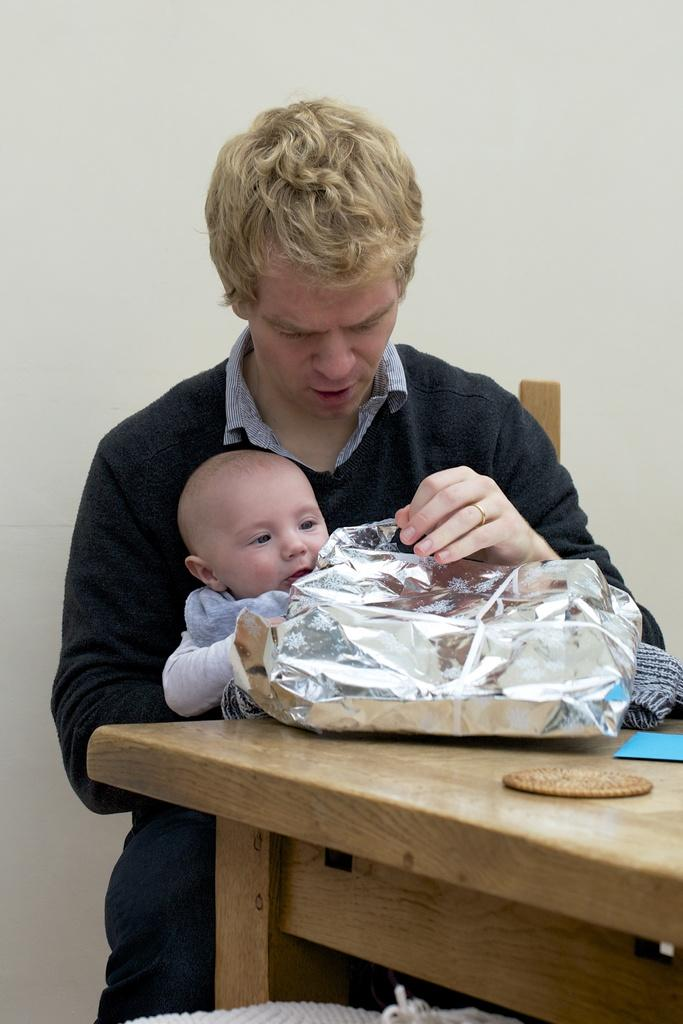Who is present in the image? There is a man in the image. What is the man doing in the image? The man is seated on a chair. Is there anyone else with the man in the image? Yes, there is a baby on the man's lap. What else can be seen in the image? There is a table in the image. What is on the table? There is a cover on the table. What type of lumber is being used to construct the door in the image? There is no door present in the image, so it is not possible to determine the type of lumber being used. 